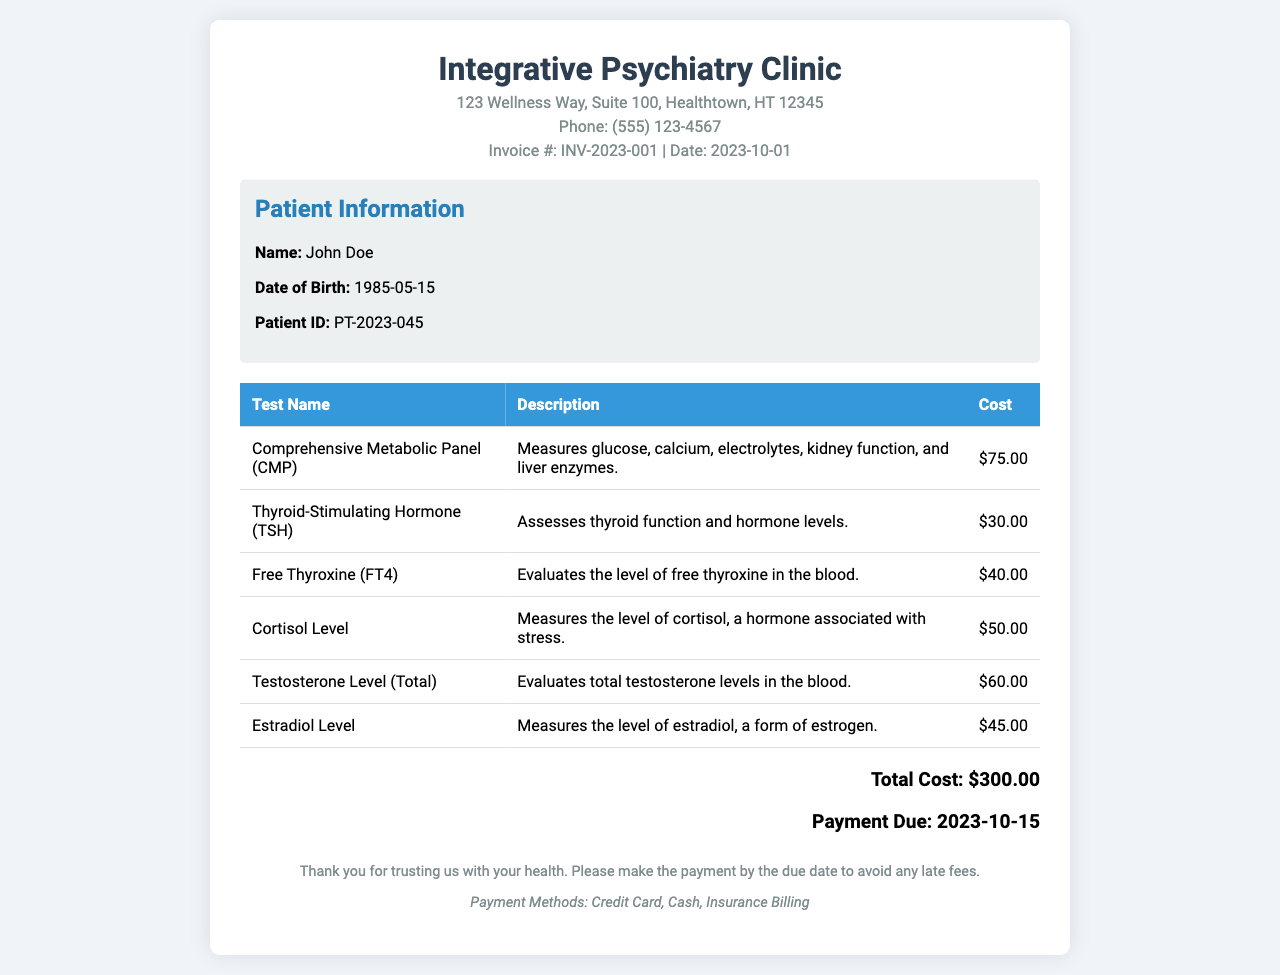What is the invoice number? The invoice number is mentioned in the document header as INV-2023-001.
Answer: INV-2023-001 What is the date of the invoice? The date is stated in the document header as 2023-10-01.
Answer: 2023-10-01 Who is the patient? The patient's name is listed in the patient info section as John Doe.
Answer: John Doe What is the total cost of the tests? The total cost is indicated in the total cost section as $300.00.
Answer: $300.00 How much does the Comprehensive Metabolic Panel cost? The cost of the Comprehensive Metabolic Panel is listed in the table as $75.00.
Answer: $75.00 What is the due date for payment? The due date for payment is stated in the total cost section as 2023-10-15.
Answer: 2023-10-15 How many hormone level assessments are included in the invoice? The invoice includes three hormone level assessments: TSH, FT4, Cortisol, and Testosterone Level.
Answer: Four What payment methods are accepted? The accepted payment methods are specified in the footer as Credit Card, Cash, Insurance Billing.
Answer: Credit Card, Cash, Insurance Billing What does the cortisol level test measure? The description for the cortisol level test indicates it measures the level of cortisol, a hormone associated with stress.
Answer: Cortisol level associated with stress 